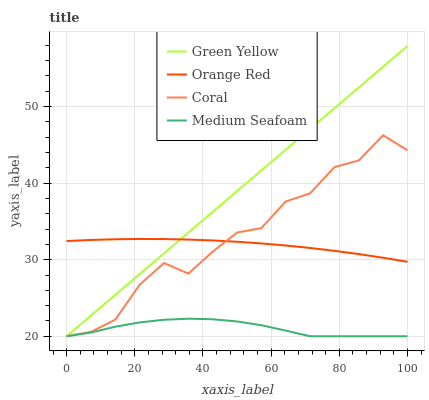Does Orange Red have the minimum area under the curve?
Answer yes or no. No. Does Orange Red have the maximum area under the curve?
Answer yes or no. No. Is Orange Red the smoothest?
Answer yes or no. No. Is Orange Red the roughest?
Answer yes or no. No. Does Orange Red have the lowest value?
Answer yes or no. No. Does Orange Red have the highest value?
Answer yes or no. No. Is Medium Seafoam less than Orange Red?
Answer yes or no. Yes. Is Orange Red greater than Medium Seafoam?
Answer yes or no. Yes. Does Medium Seafoam intersect Orange Red?
Answer yes or no. No. 